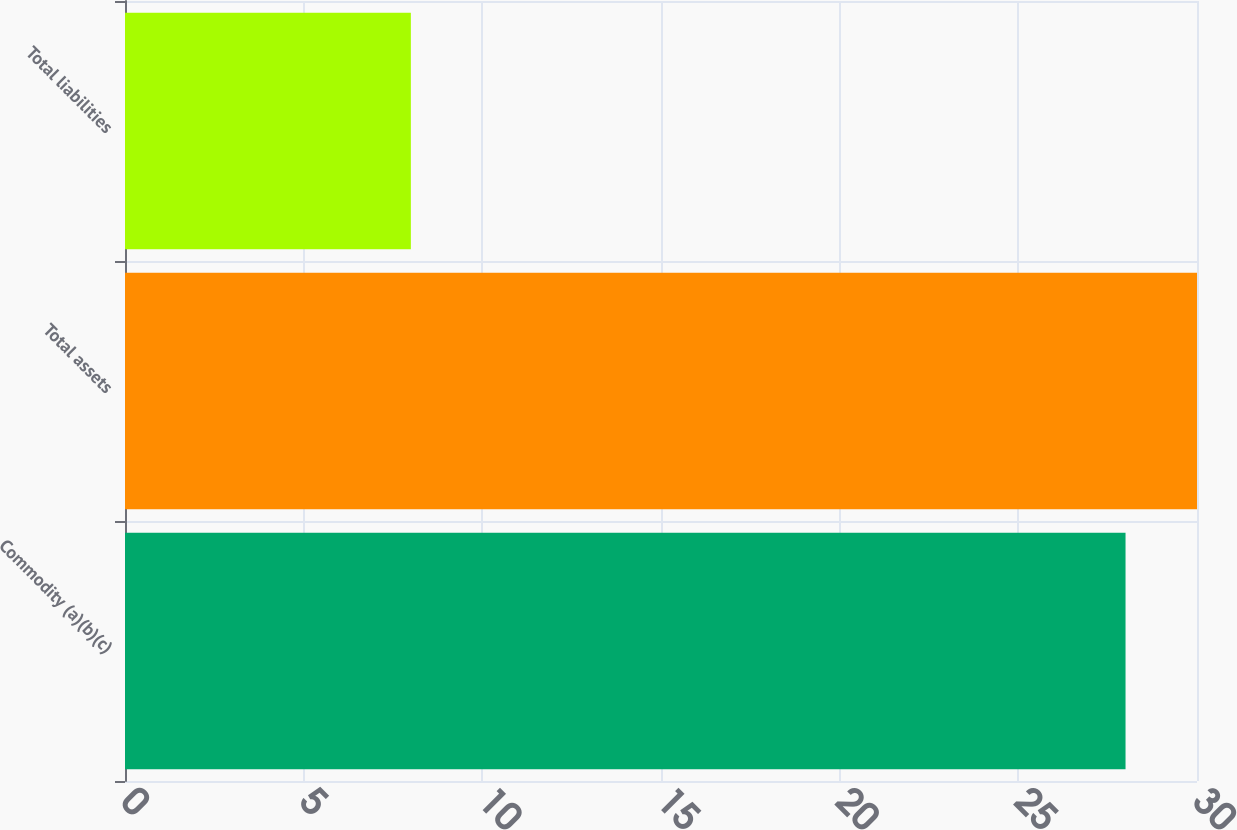<chart> <loc_0><loc_0><loc_500><loc_500><bar_chart><fcel>Commodity (a)(b)(c)<fcel>Total assets<fcel>Total liabilities<nl><fcel>28<fcel>30<fcel>8<nl></chart> 